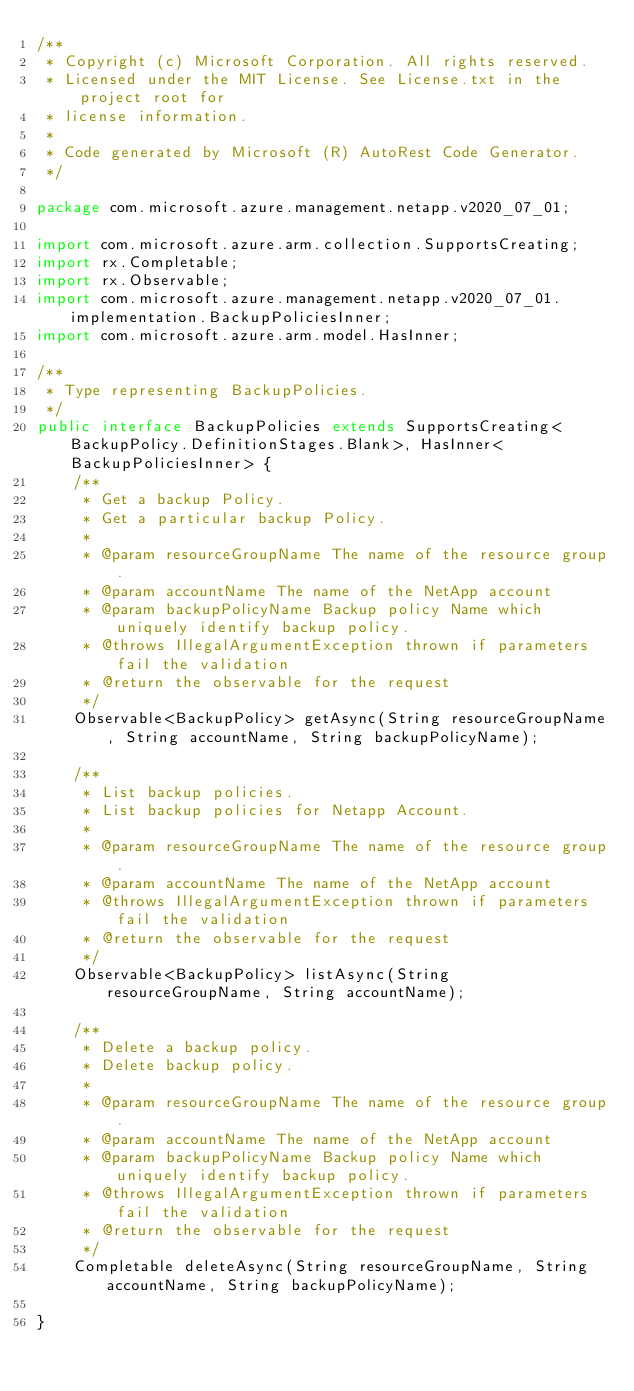Convert code to text. <code><loc_0><loc_0><loc_500><loc_500><_Java_>/**
 * Copyright (c) Microsoft Corporation. All rights reserved.
 * Licensed under the MIT License. See License.txt in the project root for
 * license information.
 *
 * Code generated by Microsoft (R) AutoRest Code Generator.
 */

package com.microsoft.azure.management.netapp.v2020_07_01;

import com.microsoft.azure.arm.collection.SupportsCreating;
import rx.Completable;
import rx.Observable;
import com.microsoft.azure.management.netapp.v2020_07_01.implementation.BackupPoliciesInner;
import com.microsoft.azure.arm.model.HasInner;

/**
 * Type representing BackupPolicies.
 */
public interface BackupPolicies extends SupportsCreating<BackupPolicy.DefinitionStages.Blank>, HasInner<BackupPoliciesInner> {
    /**
     * Get a backup Policy.
     * Get a particular backup Policy.
     *
     * @param resourceGroupName The name of the resource group.
     * @param accountName The name of the NetApp account
     * @param backupPolicyName Backup policy Name which uniquely identify backup policy.
     * @throws IllegalArgumentException thrown if parameters fail the validation
     * @return the observable for the request
     */
    Observable<BackupPolicy> getAsync(String resourceGroupName, String accountName, String backupPolicyName);

    /**
     * List backup policies.
     * List backup policies for Netapp Account.
     *
     * @param resourceGroupName The name of the resource group.
     * @param accountName The name of the NetApp account
     * @throws IllegalArgumentException thrown if parameters fail the validation
     * @return the observable for the request
     */
    Observable<BackupPolicy> listAsync(String resourceGroupName, String accountName);

    /**
     * Delete a backup policy.
     * Delete backup policy.
     *
     * @param resourceGroupName The name of the resource group.
     * @param accountName The name of the NetApp account
     * @param backupPolicyName Backup policy Name which uniquely identify backup policy.
     * @throws IllegalArgumentException thrown if parameters fail the validation
     * @return the observable for the request
     */
    Completable deleteAsync(String resourceGroupName, String accountName, String backupPolicyName);

}
</code> 